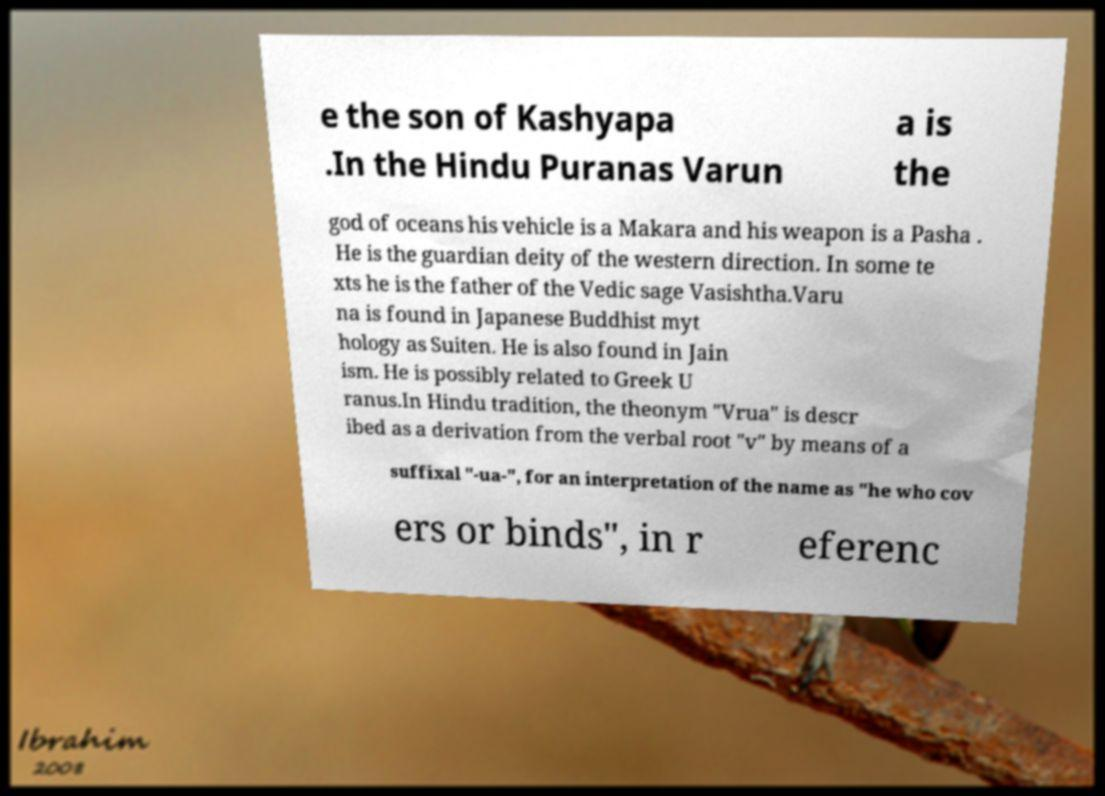Could you extract and type out the text from this image? e the son of Kashyapa .In the Hindu Puranas Varun a is the god of oceans his vehicle is a Makara and his weapon is a Pasha . He is the guardian deity of the western direction. In some te xts he is the father of the Vedic sage Vasishtha.Varu na is found in Japanese Buddhist myt hology as Suiten. He is also found in Jain ism. He is possibly related to Greek U ranus.In Hindu tradition, the theonym "Vrua" is descr ibed as a derivation from the verbal root "v" by means of a suffixal "-ua-", for an interpretation of the name as "he who cov ers or binds", in r eferenc 